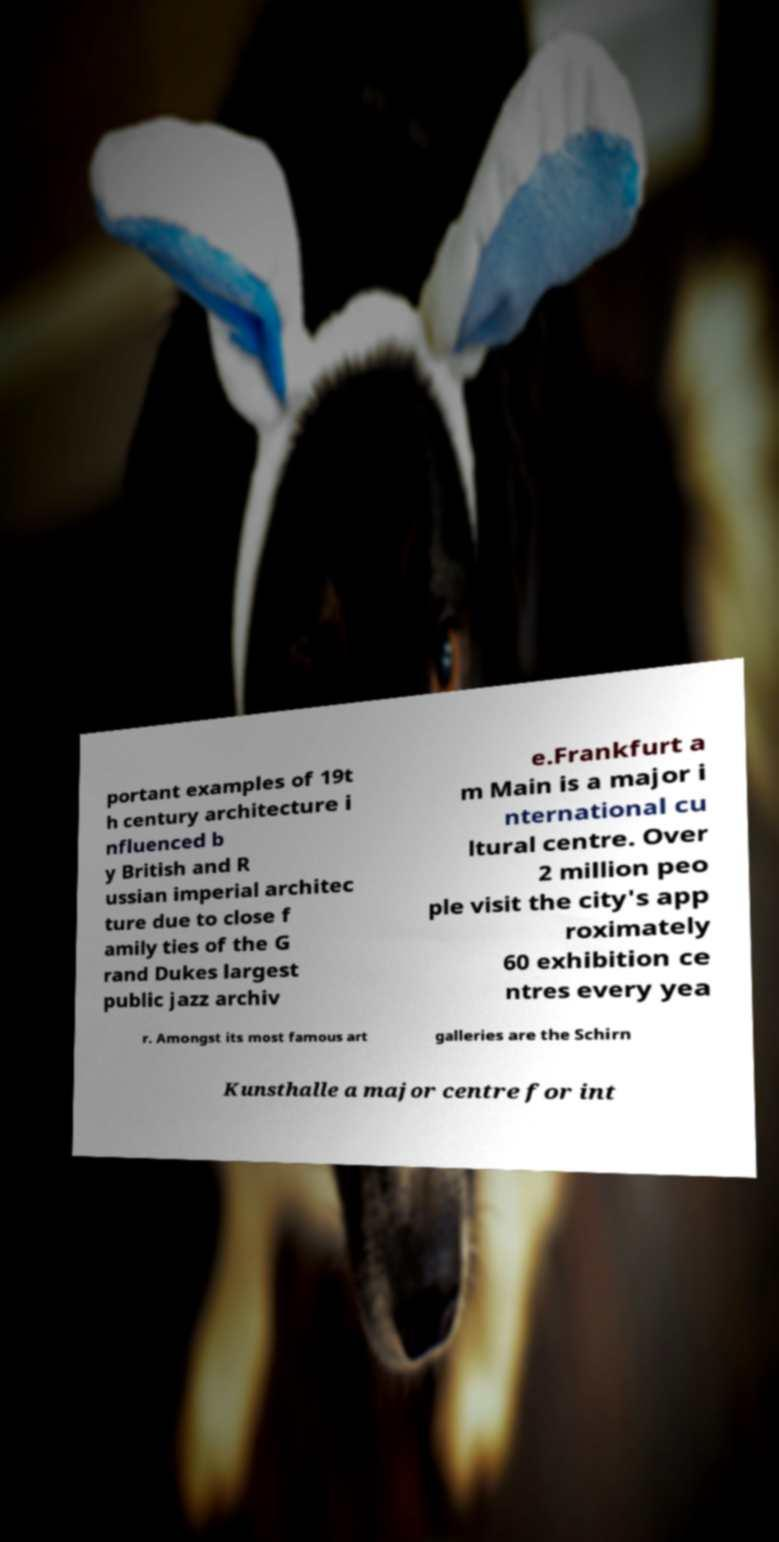What messages or text are displayed in this image? I need them in a readable, typed format. portant examples of 19t h century architecture i nfluenced b y British and R ussian imperial architec ture due to close f amily ties of the G rand Dukes largest public jazz archiv e.Frankfurt a m Main is a major i nternational cu ltural centre. Over 2 million peo ple visit the city's app roximately 60 exhibition ce ntres every yea r. Amongst its most famous art galleries are the Schirn Kunsthalle a major centre for int 